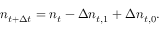<formula> <loc_0><loc_0><loc_500><loc_500>n _ { t + \Delta t } = n _ { t } - \Delta n _ { t , 1 } + \Delta n _ { t , 0 } .</formula> 